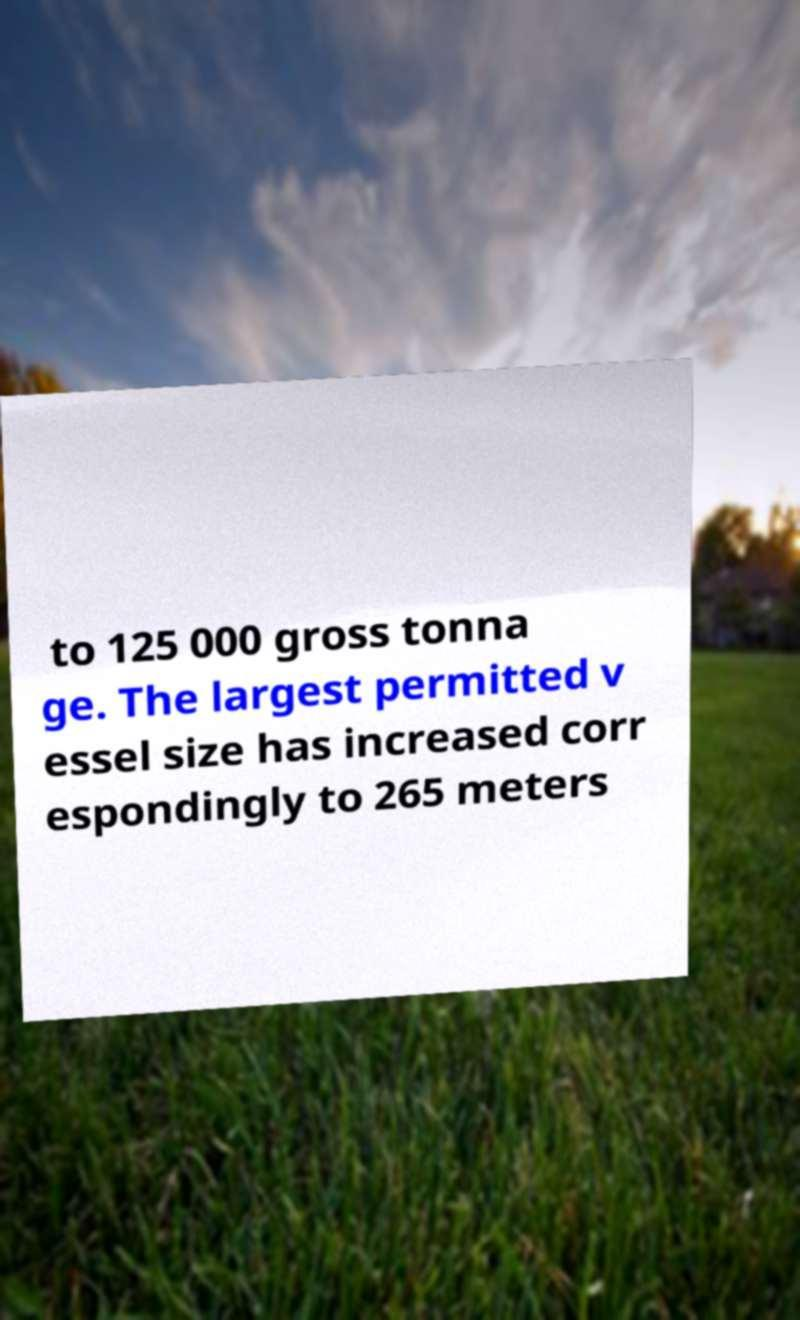What messages or text are displayed in this image? I need them in a readable, typed format. to 125 000 gross tonna ge. The largest permitted v essel size has increased corr espondingly to 265 meters 